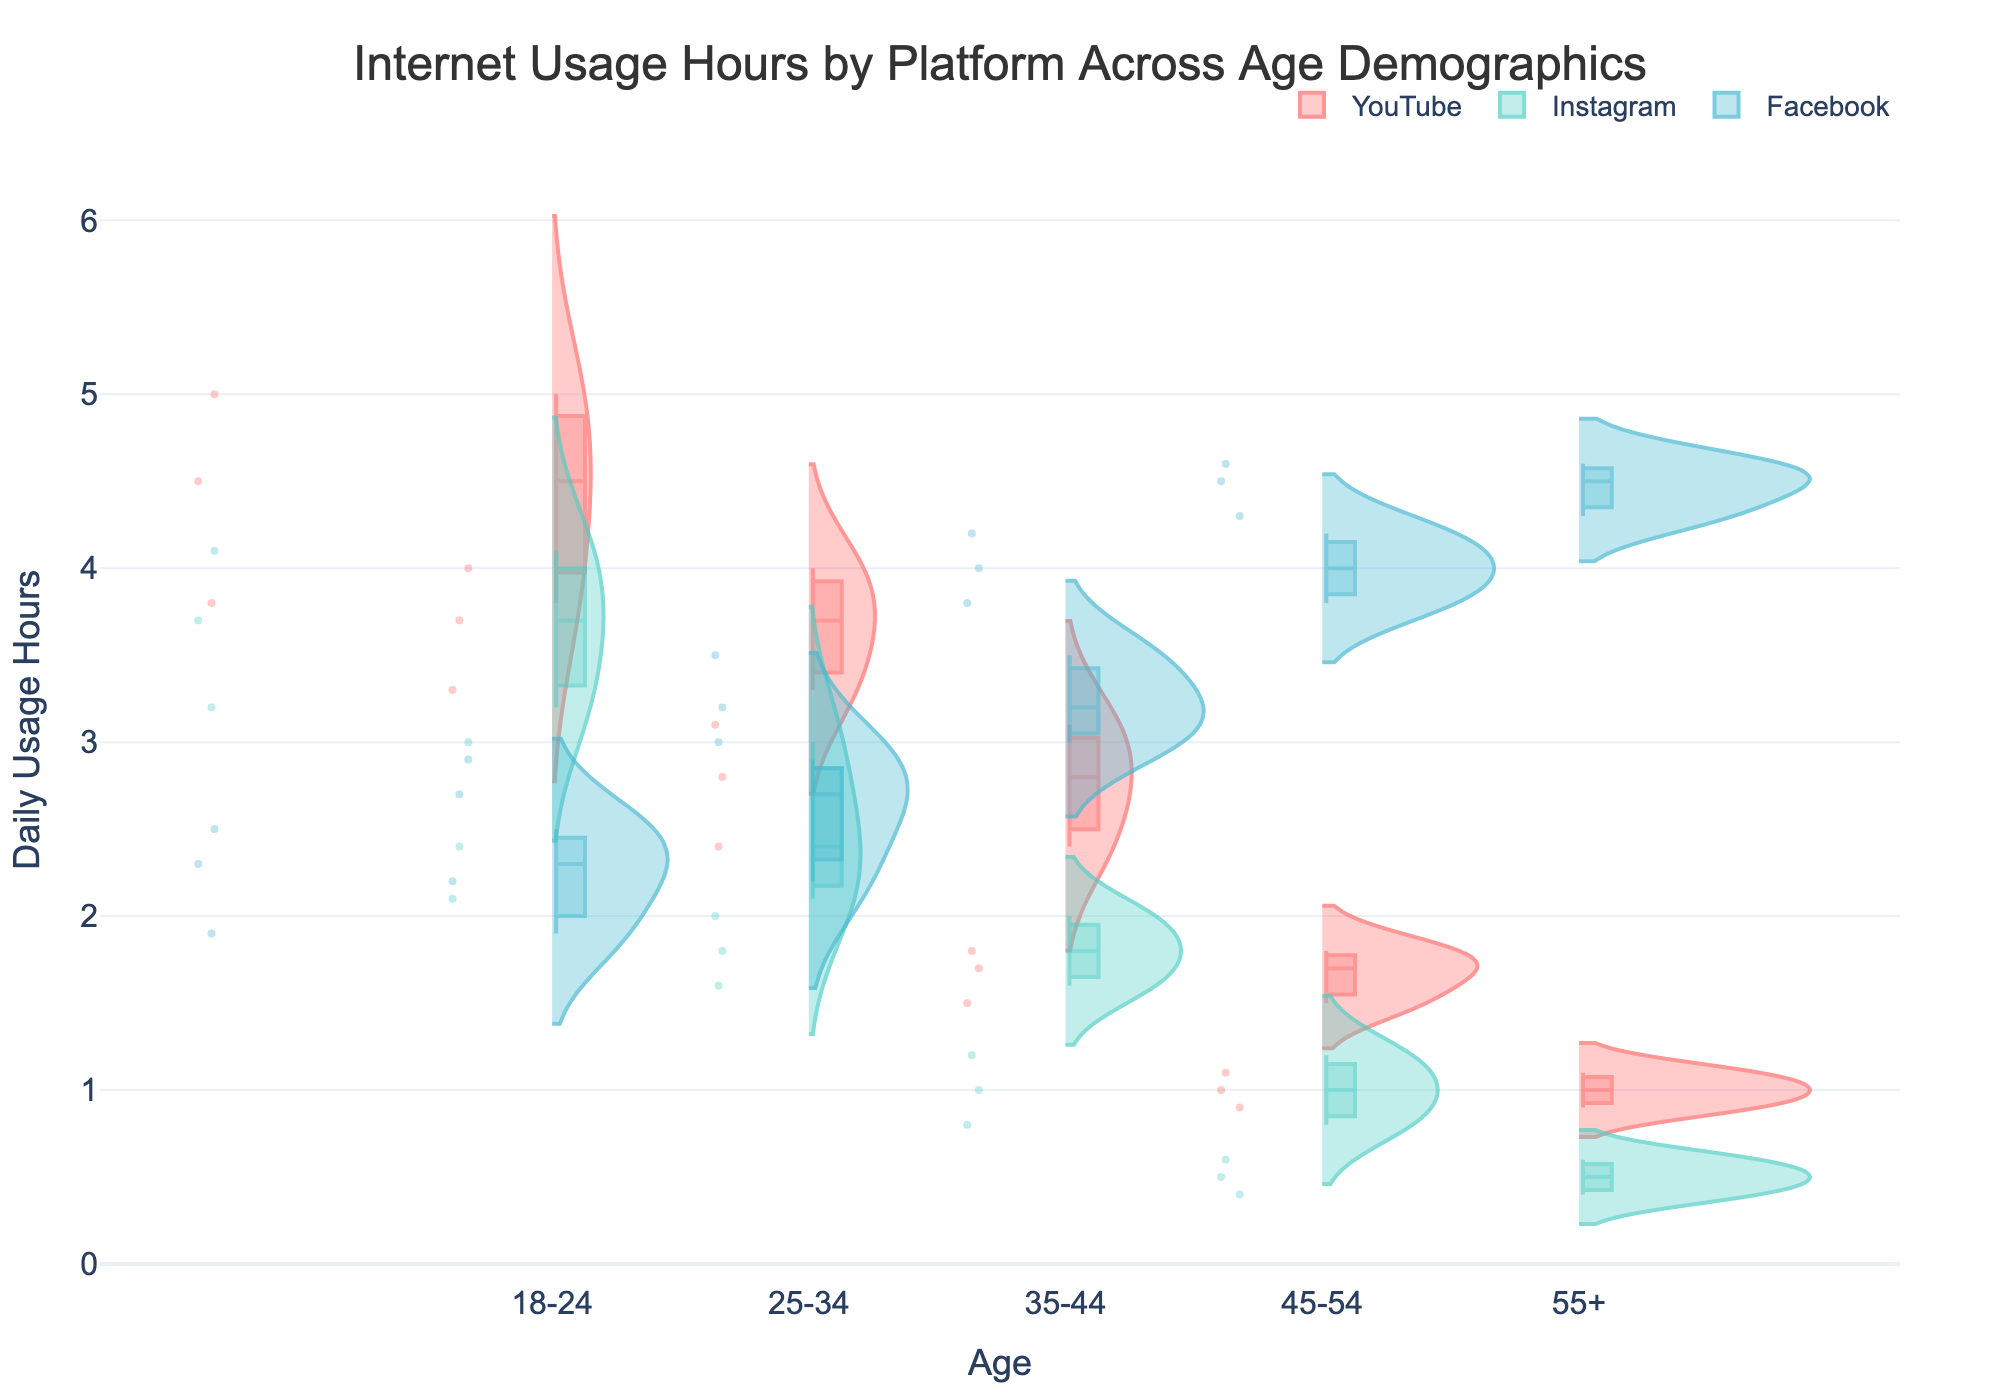What is the title of the figure? The title is typically at the top of the figure and is usually the largest text. In this case, it reads "Internet Usage Hours by Platform Across Age Demographics".
Answer: Internet Usage Hours by Platform Across Age Demographics Which platform has the highest maximum usage hours for the 55+ age group? By examining each age group and the spread of usage hours within each platform, for the 55+ age group, the highest maximum is in the Facebook platform, which spans up to around 4.6 hours.
Answer: Facebook What is the median usage hour for Instagram in the 18-24 age group? The median is indicated by the central line in the box plot within the violin plot. For Instagram in the 18-24 age group, the central line is around 3.7 hours.
Answer: 3.7 hours Which age group has the lowest median usage hours on YouTube? Looking at the median lines in the violin plots across different age groups for YouTube, the 55+ age group shows the lowest median value, around 1.0 hours.
Answer: 55+ How does the spread of usage hours for Facebook in the 45-54 age group compare to the usage hours for YouTube in the same age group? The spread (interquartile range and overall distribution) for Facebook in the 45-54 age group is higher, ranging roughly from 3.8 to 4.2 hours, whereas for YouTube, it ranges from approximately 1.5 to 1.8 hours.
Answer: Facebook has a wider spread Which platform shows the smallest usage hour spread in the 35-44 age group? For the 35-44 age group, Instagram shows a smaller spread in the usage hours, ranging from about 1.6 to 2.0 hours.
Answer: Instagram Across all age groups, which platform's usage shows the highest variance? By observing the width and length of the violin plots for each platform, Facebook displays the highest variance across all age groups, with a wide spread of data points.
Answer: Facebook What are the interquartile ranges (IQR) for Instagram in the 25-34 age group? The IQR is found between the first (25th percentile) and the third (75th percentile) quartiles. For Instagram in the 25-34 age group, it spans from approximately 2.1 to 3.0 hours.
Answer: 0.9 hours Identify the outliers in usage hours for Instagram in the 45-54 age group. Outliers in a violin plot are often marked with separate dots outside the main distribution. For Instagram in the 45-54 age group, an outlier is around 1.2 hours.
Answer: 1.2 hours 